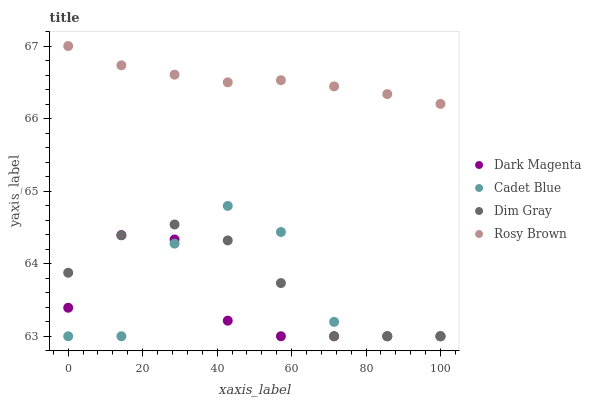Does Dark Magenta have the minimum area under the curve?
Answer yes or no. Yes. Does Rosy Brown have the maximum area under the curve?
Answer yes or no. Yes. Does Cadet Blue have the minimum area under the curve?
Answer yes or no. No. Does Cadet Blue have the maximum area under the curve?
Answer yes or no. No. Is Rosy Brown the smoothest?
Answer yes or no. Yes. Is Cadet Blue the roughest?
Answer yes or no. Yes. Is Dark Magenta the smoothest?
Answer yes or no. No. Is Dark Magenta the roughest?
Answer yes or no. No. Does Dim Gray have the lowest value?
Answer yes or no. Yes. Does Rosy Brown have the lowest value?
Answer yes or no. No. Does Rosy Brown have the highest value?
Answer yes or no. Yes. Does Cadet Blue have the highest value?
Answer yes or no. No. Is Dim Gray less than Rosy Brown?
Answer yes or no. Yes. Is Rosy Brown greater than Dark Magenta?
Answer yes or no. Yes. Does Cadet Blue intersect Dim Gray?
Answer yes or no. Yes. Is Cadet Blue less than Dim Gray?
Answer yes or no. No. Is Cadet Blue greater than Dim Gray?
Answer yes or no. No. Does Dim Gray intersect Rosy Brown?
Answer yes or no. No. 